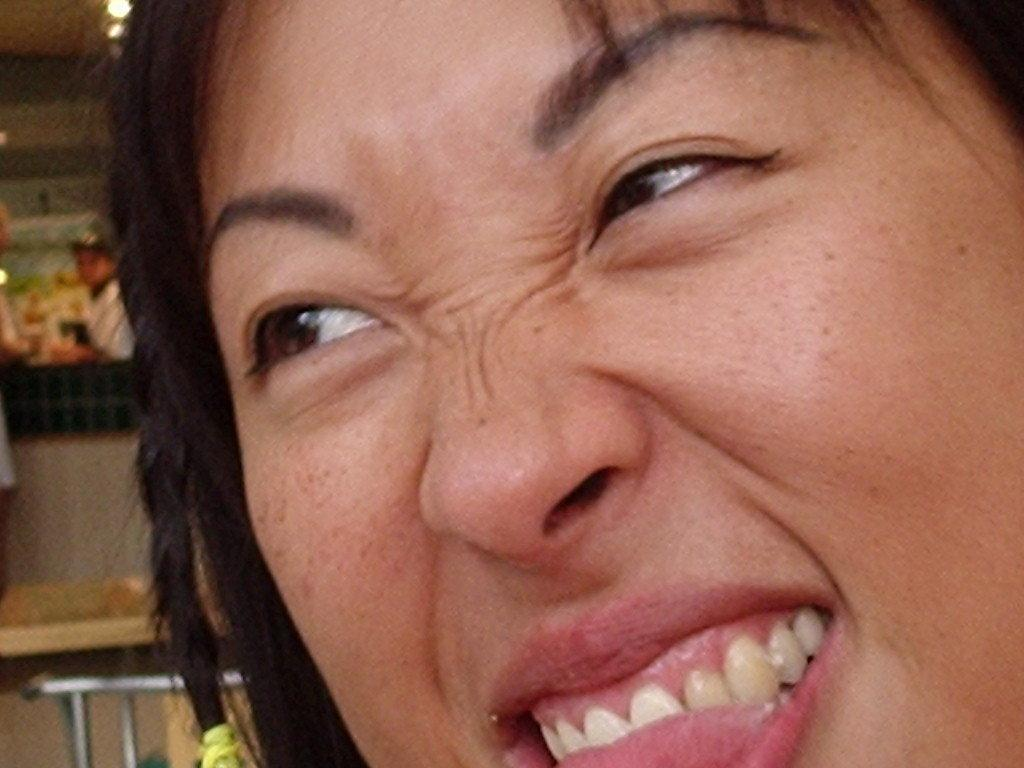What is the main subject of the image? There is a woman's face in the image. What can be observed about the woman's expression? The woman is giving an expression in the image. What can be seen in the background of the image? There is a table visible in the background of the image. What is placed on the table? There are objects placed on the table. How many windows can be seen in the image? There are no windows visible in the image; it primarily focuses on the woman's face. What type of pet is sitting on the table in the image? There is no pet present in the image; the focus is on the woman's face and the table in the background. 